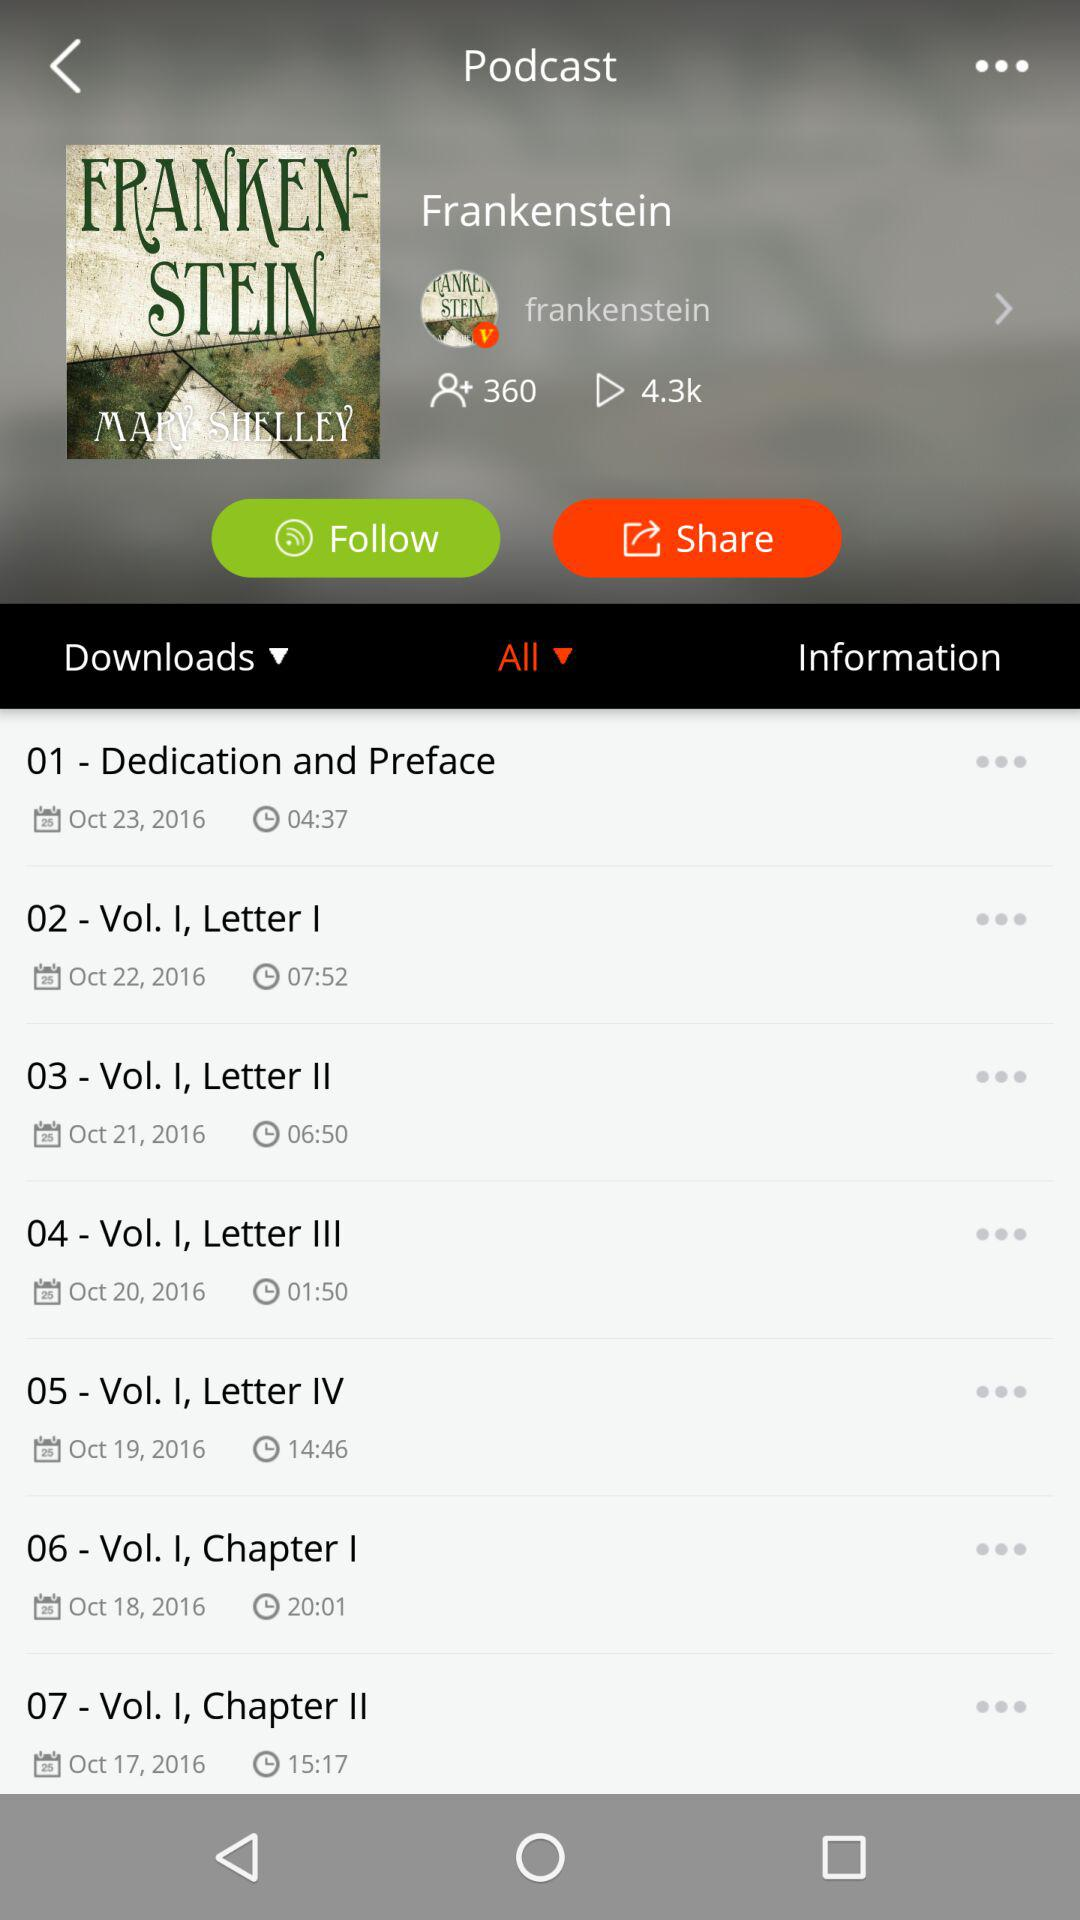How many episodes are in this podcast?
Answer the question using a single word or phrase. 7 